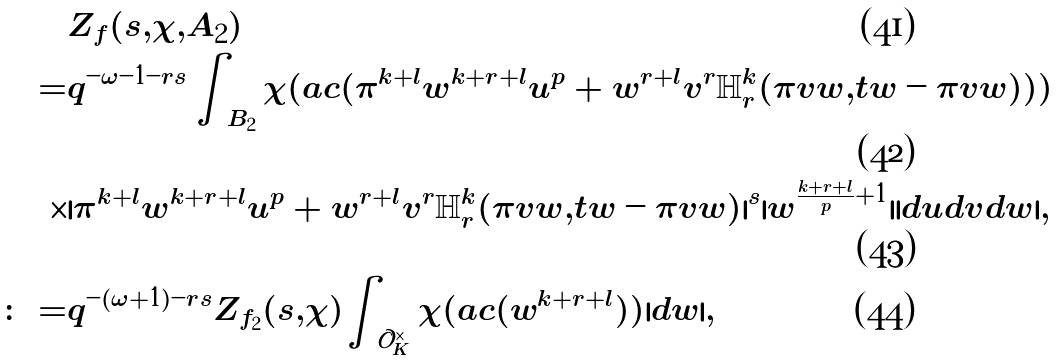<formula> <loc_0><loc_0><loc_500><loc_500>& Z _ { f } ( s , \chi , A _ { 2 } ) \\ = & q ^ { - \omega - 1 - r s } \int _ { B _ { 2 } } \chi ( a c ( \pi ^ { k + l } w ^ { k + r + l } u ^ { p } + w ^ { r + l } v ^ { r } \mathbb { H } _ { r } ^ { k } ( \pi v w , t w - \pi v w ) ) ) \\ \times & | \pi ^ { k + l } w ^ { k + r + l } u ^ { p } + w ^ { r + l } v ^ { r } \mathbb { H } _ { r } ^ { k } ( \pi v w , t w - \pi v w ) | ^ { s } | w ^ { \frac { k + r + l } { p } + 1 } | | d u d v d w | , \\ \colon = & q ^ { - ( \omega + 1 ) - r s } Z _ { f _ { 2 } } ( s , \chi ) \int _ { \mathcal { O } _ { K } ^ { \times } } \chi ( a c ( w ^ { k + r + l } ) ) | d w | ,</formula> 